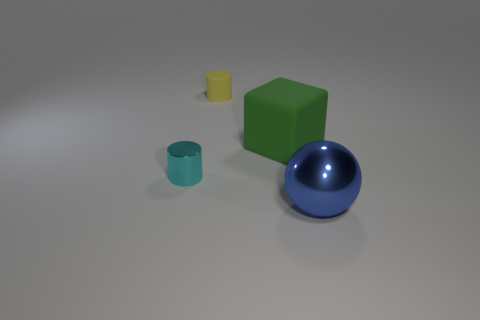Add 1 blue rubber objects. How many objects exist? 5 Subtract all spheres. How many objects are left? 3 Subtract all green cubes. Subtract all small yellow objects. How many objects are left? 2 Add 1 small cylinders. How many small cylinders are left? 3 Add 4 metal spheres. How many metal spheres exist? 5 Subtract 0 purple balls. How many objects are left? 4 